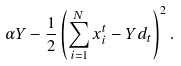Convert formula to latex. <formula><loc_0><loc_0><loc_500><loc_500>\alpha Y - \frac { 1 } { 2 } \left ( \sum _ { i = 1 } ^ { N } { x } _ { i } ^ { t } - Y d _ { t } \right ) ^ { 2 } .</formula> 